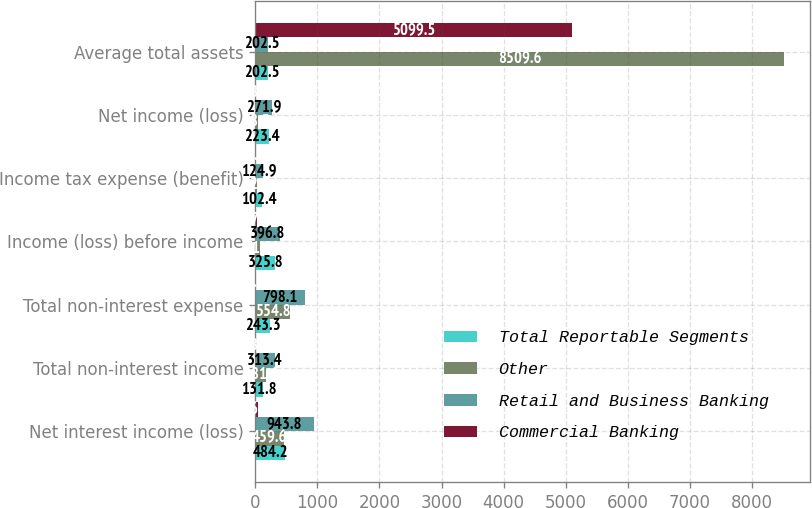Convert chart to OTSL. <chart><loc_0><loc_0><loc_500><loc_500><stacked_bar_chart><ecel><fcel>Net interest income (loss)<fcel>Total non-interest income<fcel>Total non-interest expense<fcel>Income (loss) before income<fcel>Income tax expense (benefit)<fcel>Net income (loss)<fcel>Average total assets<nl><fcel>Total Reportable Segments<fcel>484.2<fcel>131.8<fcel>243.3<fcel>325.8<fcel>102.4<fcel>223.4<fcel>202.5<nl><fcel>Other<fcel>459.6<fcel>181.6<fcel>554.8<fcel>71<fcel>22.5<fcel>48.5<fcel>8509.6<nl><fcel>Retail and Business Banking<fcel>943.8<fcel>313.4<fcel>798.1<fcel>396.8<fcel>124.9<fcel>271.9<fcel>202.5<nl><fcel>Commercial Banking<fcel>46.5<fcel>18<fcel>1.2<fcel>27.3<fcel>8.7<fcel>18.6<fcel>5099.5<nl></chart> 